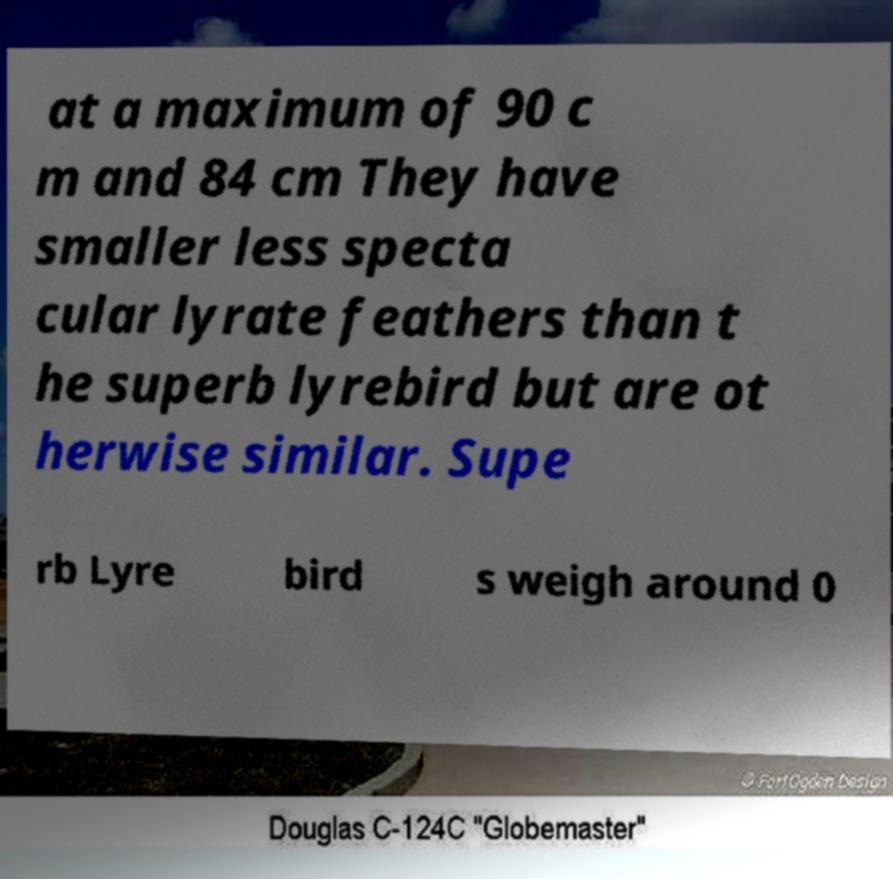Could you assist in decoding the text presented in this image and type it out clearly? at a maximum of 90 c m and 84 cm They have smaller less specta cular lyrate feathers than t he superb lyrebird but are ot herwise similar. Supe rb Lyre bird s weigh around 0 